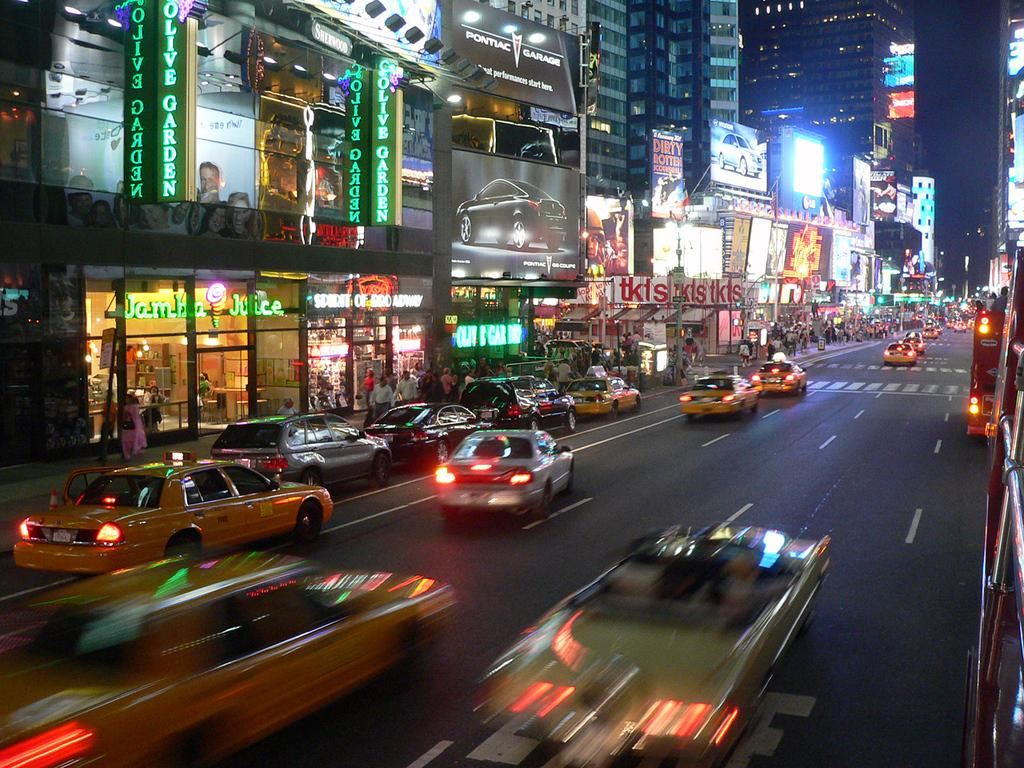<image>
Describe the image concisely. a busy city street with an olive garden restaurant on the corner. 